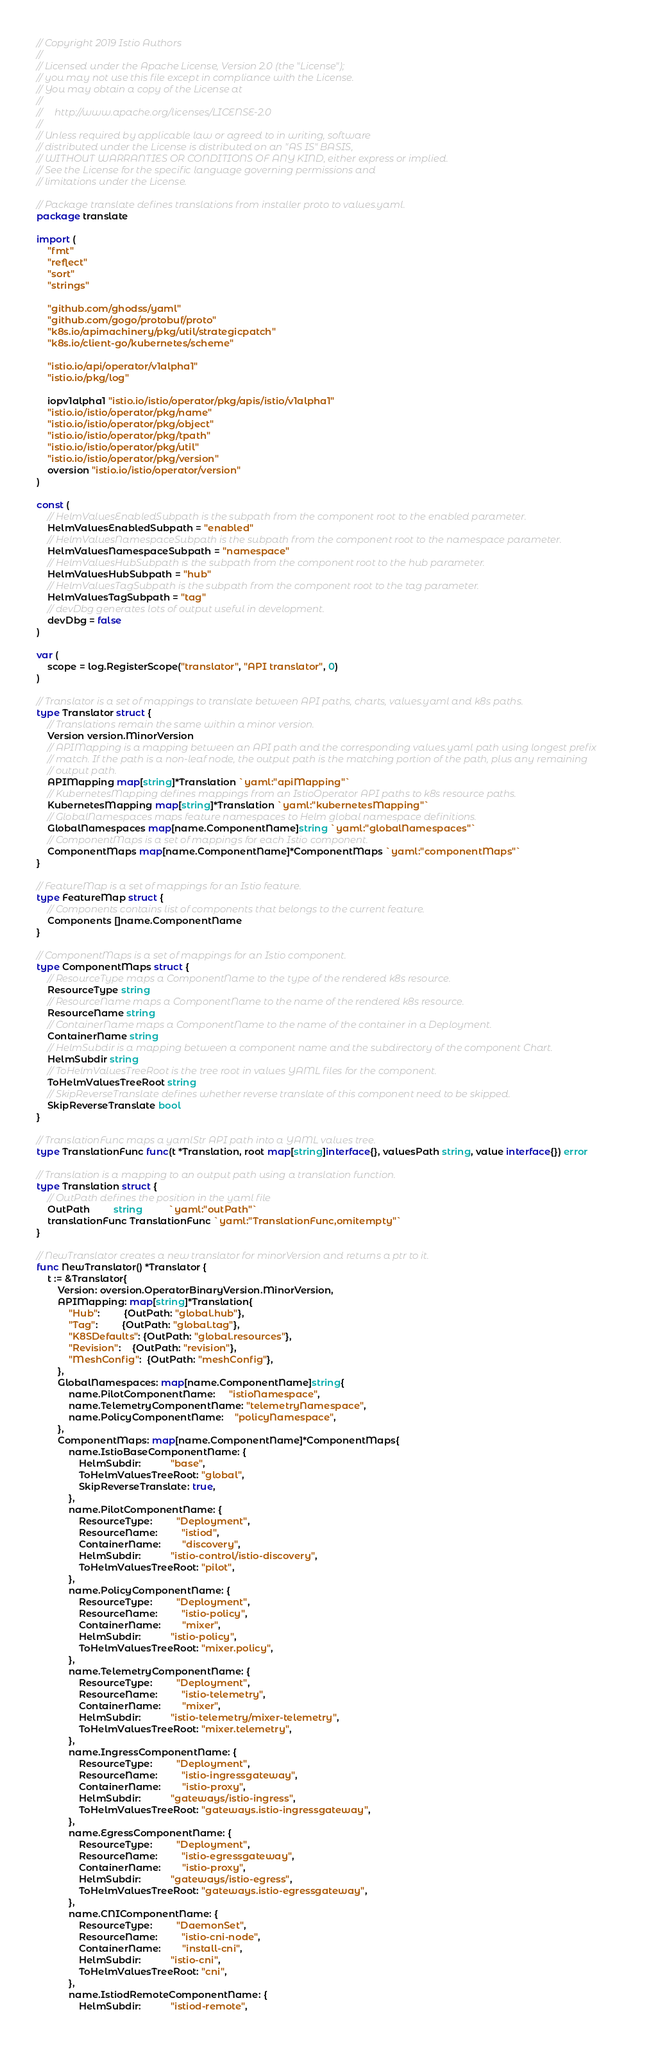<code> <loc_0><loc_0><loc_500><loc_500><_Go_>// Copyright 2019 Istio Authors
//
// Licensed under the Apache License, Version 2.0 (the "License");
// you may not use this file except in compliance with the License.
// You may obtain a copy of the License at
//
//     http://www.apache.org/licenses/LICENSE-2.0
//
// Unless required by applicable law or agreed to in writing, software
// distributed under the License is distributed on an "AS IS" BASIS,
// WITHOUT WARRANTIES OR CONDITIONS OF ANY KIND, either express or implied.
// See the License for the specific language governing permissions and
// limitations under the License.

// Package translate defines translations from installer proto to values.yaml.
package translate

import (
	"fmt"
	"reflect"
	"sort"
	"strings"

	"github.com/ghodss/yaml"
	"github.com/gogo/protobuf/proto"
	"k8s.io/apimachinery/pkg/util/strategicpatch"
	"k8s.io/client-go/kubernetes/scheme"

	"istio.io/api/operator/v1alpha1"
	"istio.io/pkg/log"

	iopv1alpha1 "istio.io/istio/operator/pkg/apis/istio/v1alpha1"
	"istio.io/istio/operator/pkg/name"
	"istio.io/istio/operator/pkg/object"
	"istio.io/istio/operator/pkg/tpath"
	"istio.io/istio/operator/pkg/util"
	"istio.io/istio/operator/pkg/version"
	oversion "istio.io/istio/operator/version"
)

const (
	// HelmValuesEnabledSubpath is the subpath from the component root to the enabled parameter.
	HelmValuesEnabledSubpath = "enabled"
	// HelmValuesNamespaceSubpath is the subpath from the component root to the namespace parameter.
	HelmValuesNamespaceSubpath = "namespace"
	// HelmValuesHubSubpath is the subpath from the component root to the hub parameter.
	HelmValuesHubSubpath = "hub"
	// HelmValuesTagSubpath is the subpath from the component root to the tag parameter.
	HelmValuesTagSubpath = "tag"
	// devDbg generates lots of output useful in development.
	devDbg = false
)

var (
	scope = log.RegisterScope("translator", "API translator", 0)
)

// Translator is a set of mappings to translate between API paths, charts, values.yaml and k8s paths.
type Translator struct {
	// Translations remain the same within a minor version.
	Version version.MinorVersion
	// APIMapping is a mapping between an API path and the corresponding values.yaml path using longest prefix
	// match. If the path is a non-leaf node, the output path is the matching portion of the path, plus any remaining
	// output path.
	APIMapping map[string]*Translation `yaml:"apiMapping"`
	// KubernetesMapping defines mappings from an IstioOperator API paths to k8s resource paths.
	KubernetesMapping map[string]*Translation `yaml:"kubernetesMapping"`
	// GlobalNamespaces maps feature namespaces to Helm global namespace definitions.
	GlobalNamespaces map[name.ComponentName]string `yaml:"globalNamespaces"`
	// ComponentMaps is a set of mappings for each Istio component.
	ComponentMaps map[name.ComponentName]*ComponentMaps `yaml:"componentMaps"`
}

// FeatureMap is a set of mappings for an Istio feature.
type FeatureMap struct {
	// Components contains list of components that belongs to the current feature.
	Components []name.ComponentName
}

// ComponentMaps is a set of mappings for an Istio component.
type ComponentMaps struct {
	// ResourceType maps a ComponentName to the type of the rendered k8s resource.
	ResourceType string
	// ResourceName maps a ComponentName to the name of the rendered k8s resource.
	ResourceName string
	// ContainerName maps a ComponentName to the name of the container in a Deployment.
	ContainerName string
	// HelmSubdir is a mapping between a component name and the subdirectory of the component Chart.
	HelmSubdir string
	// ToHelmValuesTreeRoot is the tree root in values YAML files for the component.
	ToHelmValuesTreeRoot string
	// SkipReverseTranslate defines whether reverse translate of this component need to be skipped.
	SkipReverseTranslate bool
}

// TranslationFunc maps a yamlStr API path into a YAML values tree.
type TranslationFunc func(t *Translation, root map[string]interface{}, valuesPath string, value interface{}) error

// Translation is a mapping to an output path using a translation function.
type Translation struct {
	// OutPath defines the position in the yaml file
	OutPath         string          `yaml:"outPath"`
	translationFunc TranslationFunc `yaml:"TranslationFunc,omitempty"`
}

// NewTranslator creates a new translator for minorVersion and returns a ptr to it.
func NewTranslator() *Translator {
	t := &Translator{
		Version: oversion.OperatorBinaryVersion.MinorVersion,
		APIMapping: map[string]*Translation{
			"Hub":         {OutPath: "global.hub"},
			"Tag":         {OutPath: "global.tag"},
			"K8SDefaults": {OutPath: "global.resources"},
			"Revision":    {OutPath: "revision"},
			"MeshConfig":  {OutPath: "meshConfig"},
		},
		GlobalNamespaces: map[name.ComponentName]string{
			name.PilotComponentName:     "istioNamespace",
			name.TelemetryComponentName: "telemetryNamespace",
			name.PolicyComponentName:    "policyNamespace",
		},
		ComponentMaps: map[name.ComponentName]*ComponentMaps{
			name.IstioBaseComponentName: {
				HelmSubdir:           "base",
				ToHelmValuesTreeRoot: "global",
				SkipReverseTranslate: true,
			},
			name.PilotComponentName: {
				ResourceType:         "Deployment",
				ResourceName:         "istiod",
				ContainerName:        "discovery",
				HelmSubdir:           "istio-control/istio-discovery",
				ToHelmValuesTreeRoot: "pilot",
			},
			name.PolicyComponentName: {
				ResourceType:         "Deployment",
				ResourceName:         "istio-policy",
				ContainerName:        "mixer",
				HelmSubdir:           "istio-policy",
				ToHelmValuesTreeRoot: "mixer.policy",
			},
			name.TelemetryComponentName: {
				ResourceType:         "Deployment",
				ResourceName:         "istio-telemetry",
				ContainerName:        "mixer",
				HelmSubdir:           "istio-telemetry/mixer-telemetry",
				ToHelmValuesTreeRoot: "mixer.telemetry",
			},
			name.IngressComponentName: {
				ResourceType:         "Deployment",
				ResourceName:         "istio-ingressgateway",
				ContainerName:        "istio-proxy",
				HelmSubdir:           "gateways/istio-ingress",
				ToHelmValuesTreeRoot: "gateways.istio-ingressgateway",
			},
			name.EgressComponentName: {
				ResourceType:         "Deployment",
				ResourceName:         "istio-egressgateway",
				ContainerName:        "istio-proxy",
				HelmSubdir:           "gateways/istio-egress",
				ToHelmValuesTreeRoot: "gateways.istio-egressgateway",
			},
			name.CNIComponentName: {
				ResourceType:         "DaemonSet",
				ResourceName:         "istio-cni-node",
				ContainerName:        "install-cni",
				HelmSubdir:           "istio-cni",
				ToHelmValuesTreeRoot: "cni",
			},
			name.IstiodRemoteComponentName: {
				HelmSubdir:           "istiod-remote",</code> 